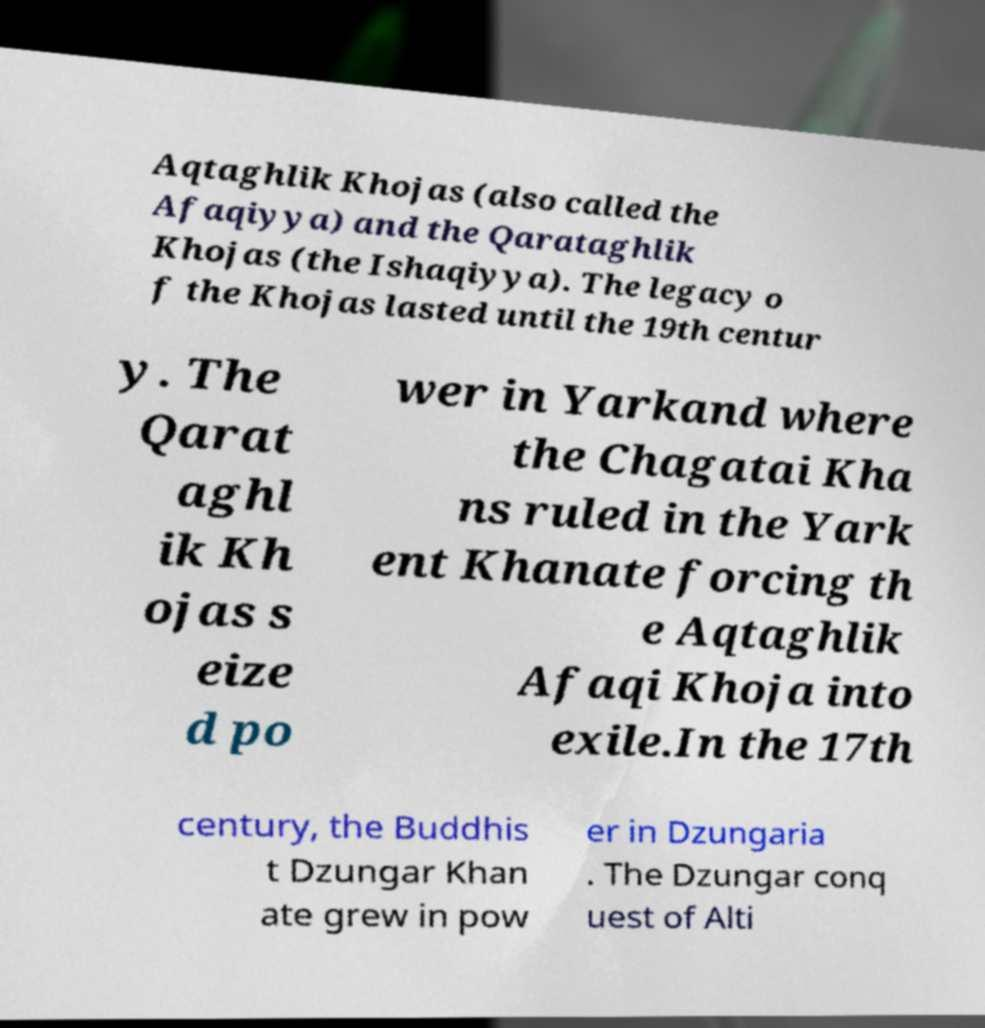Please read and relay the text visible in this image. What does it say? Aqtaghlik Khojas (also called the Afaqiyya) and the Qarataghlik Khojas (the Ishaqiyya). The legacy o f the Khojas lasted until the 19th centur y. The Qarat aghl ik Kh ojas s eize d po wer in Yarkand where the Chagatai Kha ns ruled in the Yark ent Khanate forcing th e Aqtaghlik Afaqi Khoja into exile.In the 17th century, the Buddhis t Dzungar Khan ate grew in pow er in Dzungaria . The Dzungar conq uest of Alti 